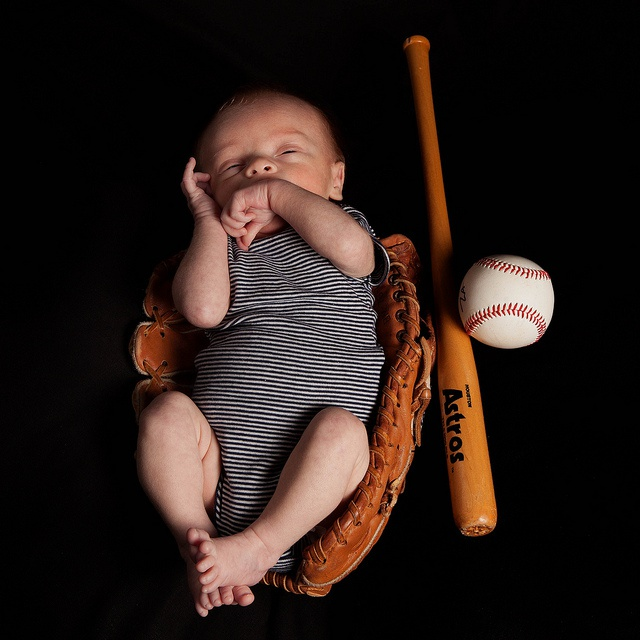Describe the objects in this image and their specific colors. I can see people in black, tan, brown, and maroon tones, baseball glove in black, maroon, and brown tones, baseball bat in black, brown, orange, and maroon tones, and sports ball in black, lightgray, and tan tones in this image. 